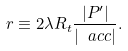Convert formula to latex. <formula><loc_0><loc_0><loc_500><loc_500>r \equiv 2 \lambda R _ { t } \frac { | P ^ { \prime } | } { | \ a c c | } .</formula> 